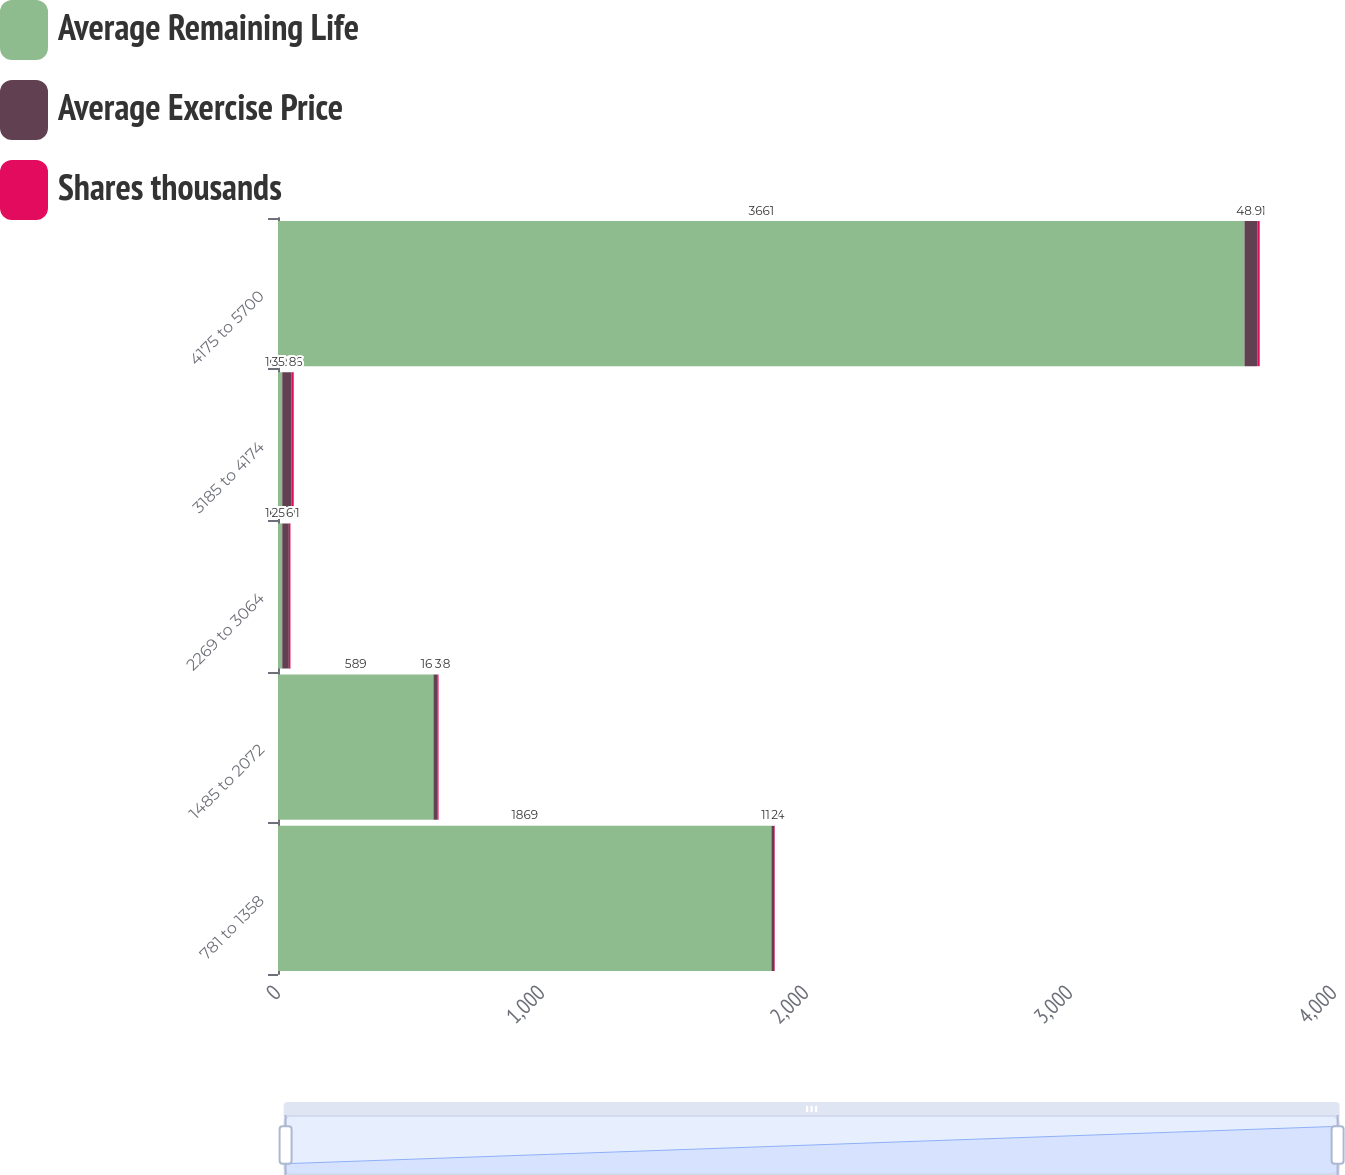Convert chart. <chart><loc_0><loc_0><loc_500><loc_500><stacked_bar_chart><ecel><fcel>781 to 1358<fcel>1485 to 2072<fcel>2269 to 3064<fcel>3185 to 4174<fcel>4175 to 5700<nl><fcel>Average Remaining Life<fcel>1869<fcel>589<fcel>16.08<fcel>16.08<fcel>3661<nl><fcel>Average Exercise Price<fcel>11.14<fcel>16.08<fcel>25.01<fcel>35.46<fcel>48.51<nl><fcel>Shares thousands<fcel>2<fcel>3<fcel>6<fcel>8<fcel>9<nl></chart> 